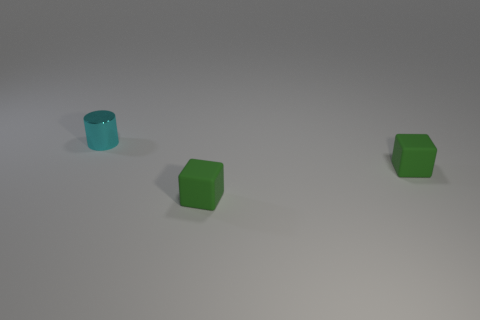What shapes are present in this image, and do they seem to be arranged in a specific pattern? The image prominently features two simple geometric shapes: cylinders and cubes. There is no discernible pattern to their arrangement; they appear to be placed randomly on the surface. What can you infer about the size of the objects? The objects appear to be relatively small, as indicated by the ample space around them on the surface. Their size suggests they could be handheld, possibly resembling common game pieces or educational models. 